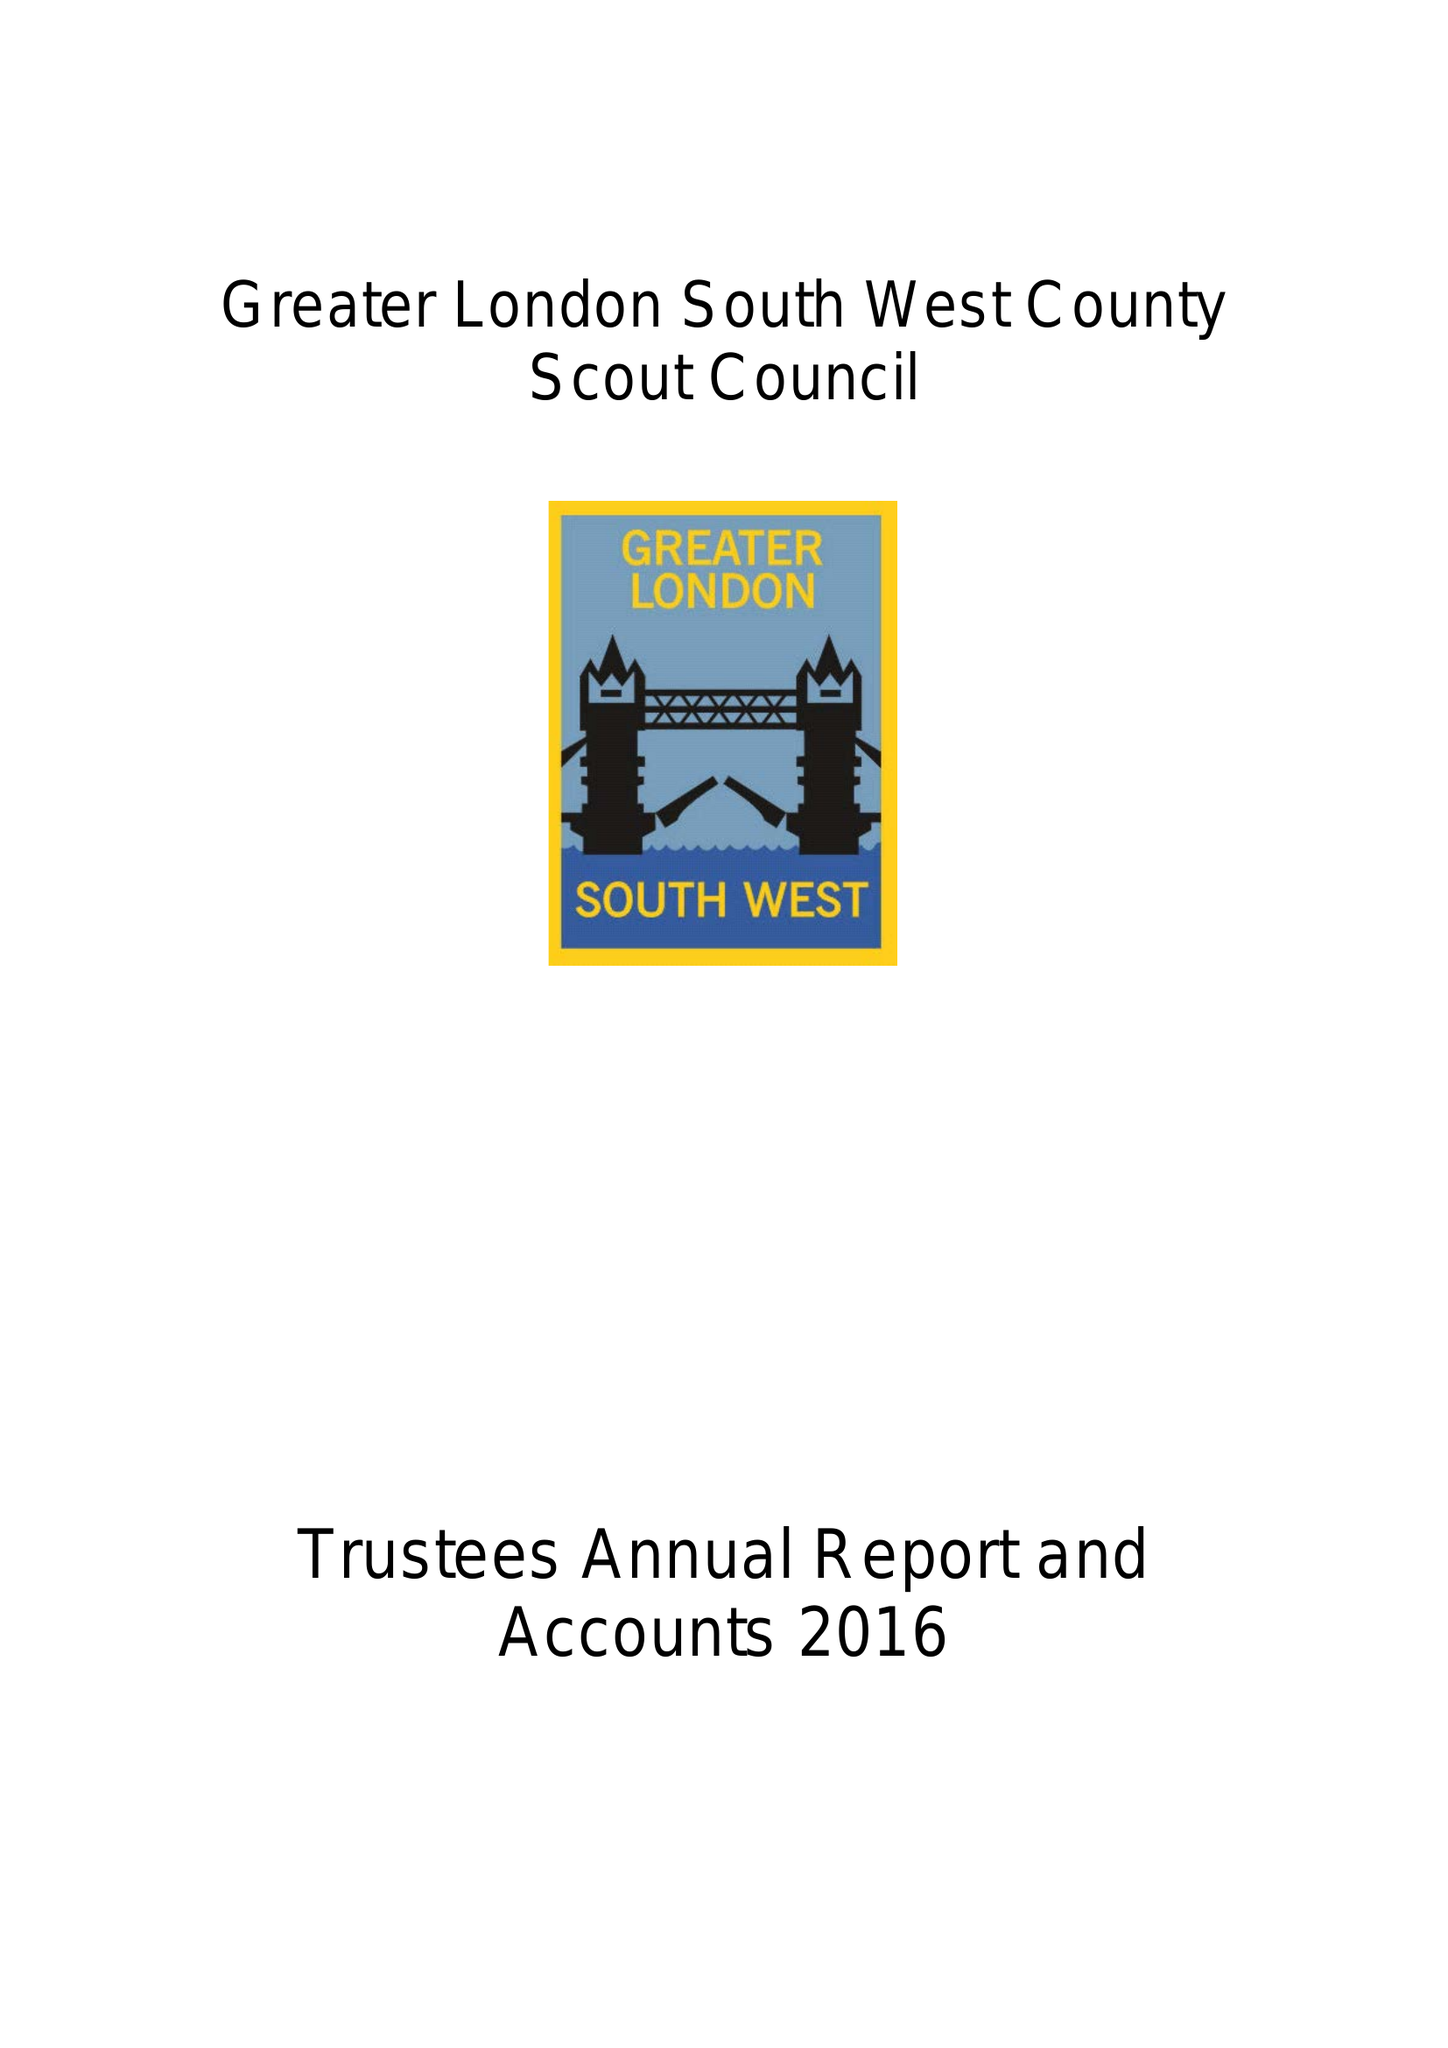What is the value for the spending_annually_in_british_pounds?
Answer the question using a single word or phrase. 82947.00 